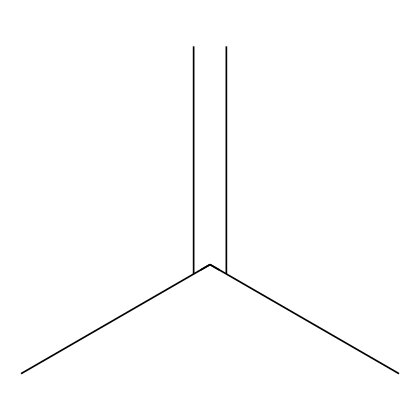What is the molecular formula of this chemical? To determine the molecular formula, we analyze the SMILES representation CC(C)=C. Here, we have 4 carbon (C) atoms and 8 hydrogen (H) atoms, resulting in the formula C4H8.
Answer: C4H8 How many carbon atoms are present in the structure? The SMILES representation indicates the presence of 4 carbon atoms (C) since we can see four 'C' symbols when breaking down CC(C)=C.
Answer: 4 What type of bonding is present in this chemical? This chemical structure includes both single bonds (between carbon atoms) and a double bond (between the last two carbon atoms). The presence of a double bond indicates unsaturation in the structure.
Answer: single and double bonds What is the functional group in this compound? By analyzing the structure, there is no specific functional group like alcohol or ketone; however, the presence of a double bond denotes it as an alkene.
Answer: alkene Does this chemical have a flash point typically associated with flammable liquids? This compound, being an alkene with low boiling points, generally has a flash point indicating it is flammable. Alkenes typically have flash points below room temperature.
Answer: yes What is the primary reason this chemical is used in aerosol spray paints? Its low viscosity and rapid evaporation properties make it a suitable propellant and solvent in aerosol applications.
Answer: low viscosity and rapid evaporation Is this chemical soluble in water? Due to the hydrophobic nature of alkenes and its carbon chain, it is generally insoluble in water.
Answer: no 